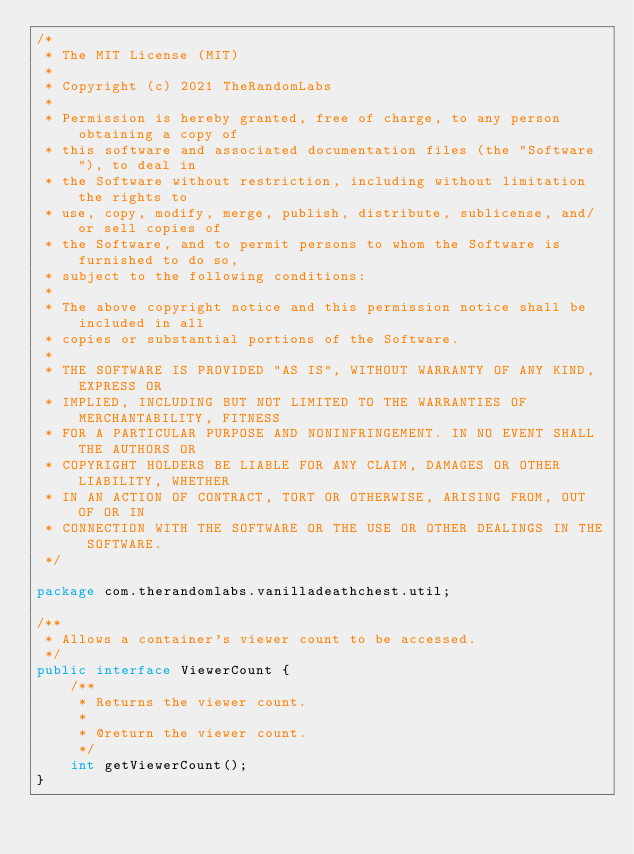Convert code to text. <code><loc_0><loc_0><loc_500><loc_500><_Java_>/*
 * The MIT License (MIT)
 *
 * Copyright (c) 2021 TheRandomLabs
 *
 * Permission is hereby granted, free of charge, to any person obtaining a copy of
 * this software and associated documentation files (the "Software"), to deal in
 * the Software without restriction, including without limitation the rights to
 * use, copy, modify, merge, publish, distribute, sublicense, and/or sell copies of
 * the Software, and to permit persons to whom the Software is furnished to do so,
 * subject to the following conditions:
 *
 * The above copyright notice and this permission notice shall be included in all
 * copies or substantial portions of the Software.
 *
 * THE SOFTWARE IS PROVIDED "AS IS", WITHOUT WARRANTY OF ANY KIND, EXPRESS OR
 * IMPLIED, INCLUDING BUT NOT LIMITED TO THE WARRANTIES OF MERCHANTABILITY, FITNESS
 * FOR A PARTICULAR PURPOSE AND NONINFRINGEMENT. IN NO EVENT SHALL THE AUTHORS OR
 * COPYRIGHT HOLDERS BE LIABLE FOR ANY CLAIM, DAMAGES OR OTHER LIABILITY, WHETHER
 * IN AN ACTION OF CONTRACT, TORT OR OTHERWISE, ARISING FROM, OUT OF OR IN
 * CONNECTION WITH THE SOFTWARE OR THE USE OR OTHER DEALINGS IN THE SOFTWARE.
 */

package com.therandomlabs.vanilladeathchest.util;

/**
 * Allows a container's viewer count to be accessed.
 */
public interface ViewerCount {
	/**
	 * Returns the viewer count.
	 *
	 * @return the viewer count.
	 */
	int getViewerCount();
}
</code> 